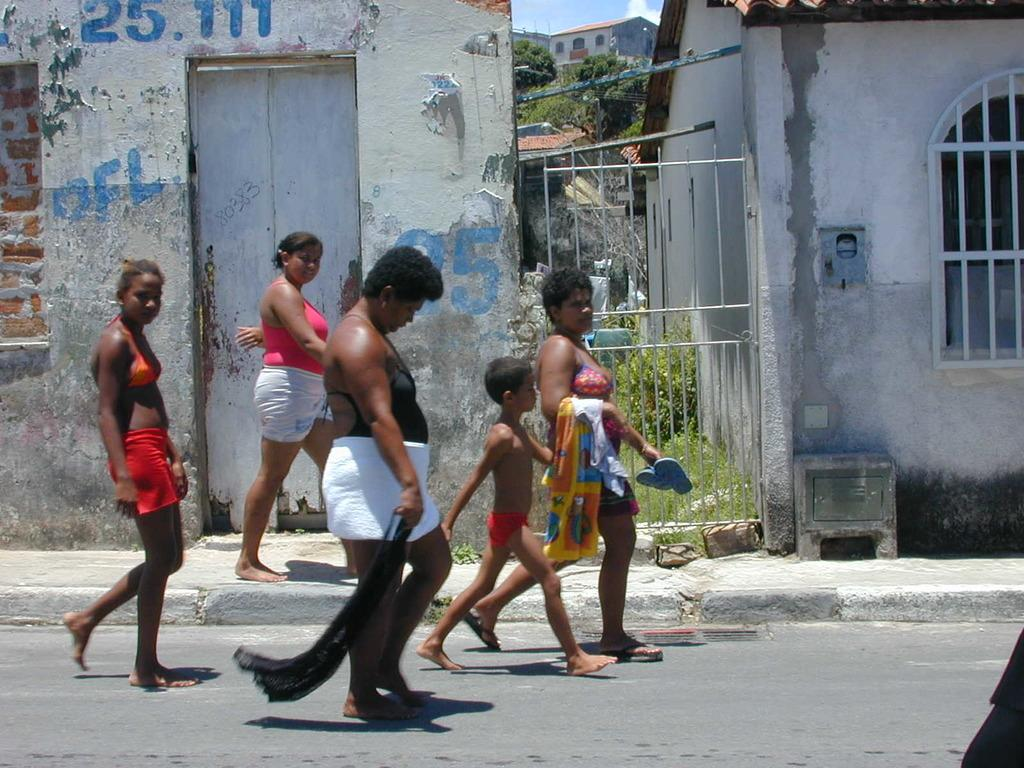What are the main subjects in the center of the image? There are persons walking in the center of the image. What can be seen in the background of the image? There are houses and trees in the background of the image. Can you describe any additional details about the houses in the background? The houses are not the main focus of the image, but they are visible in the background. What is written on the wall of a house in the center of the image? There is text written on the wall of a house in the center of the image. How many planes are flying over the trees in the image? There are no planes visible in the image; it only shows persons walking, houses, and trees. 